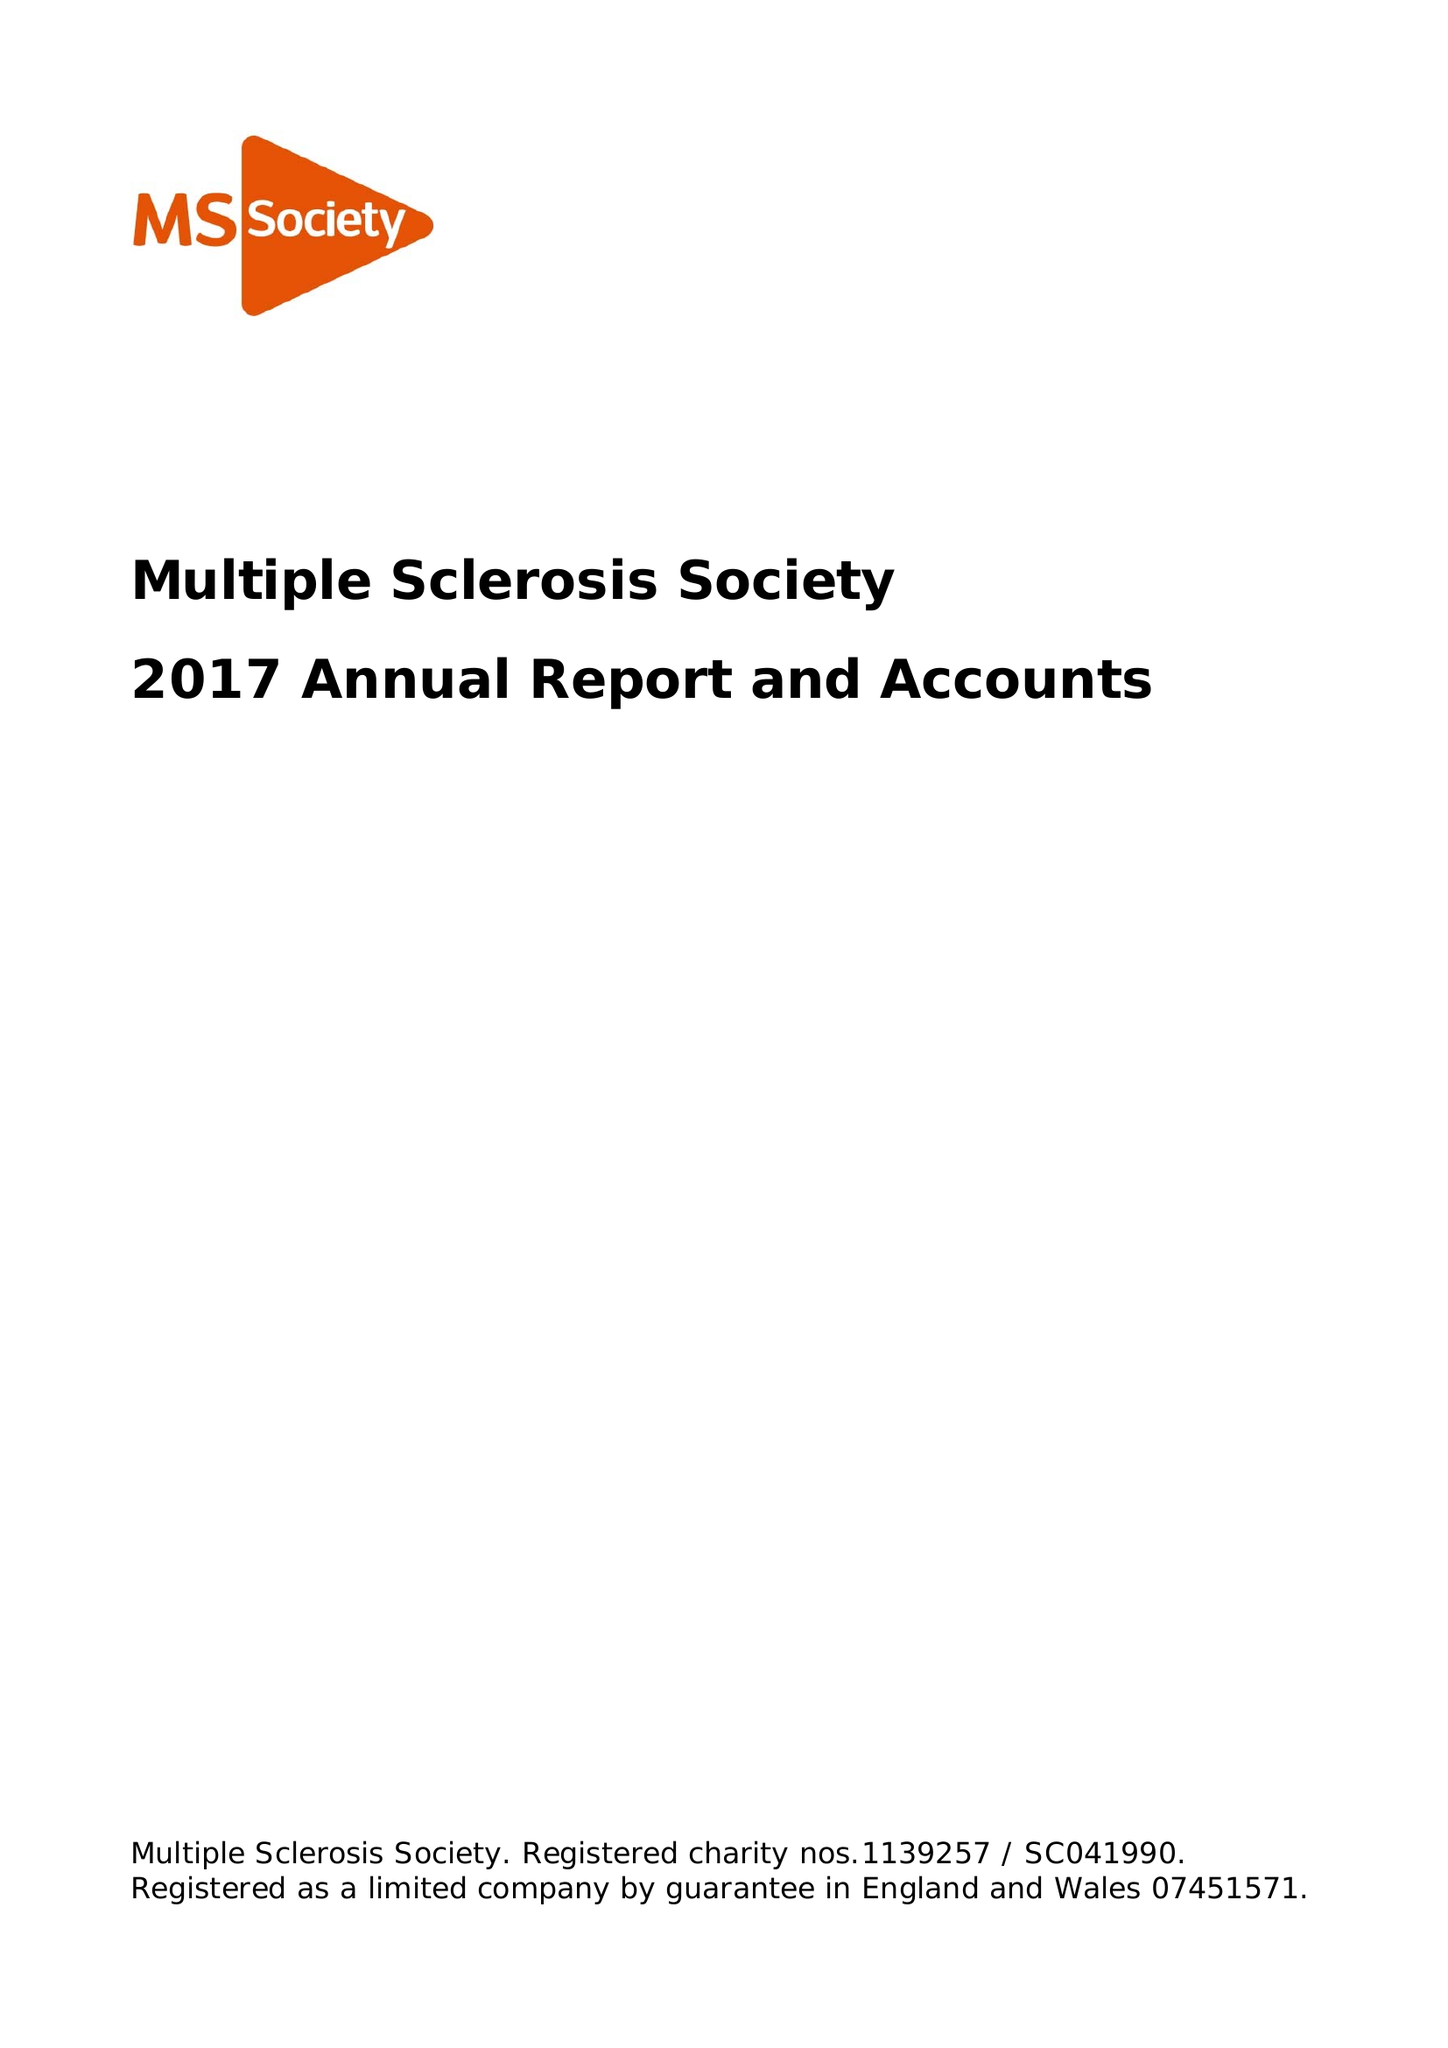What is the value for the income_annually_in_british_pounds?
Answer the question using a single word or phrase. 28852000.00 